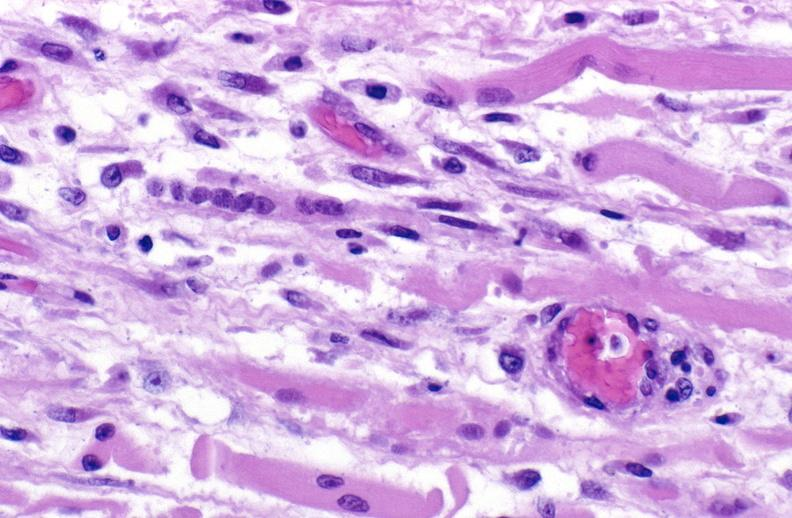what is present?
Answer the question using a single word or phrase. Muscle 